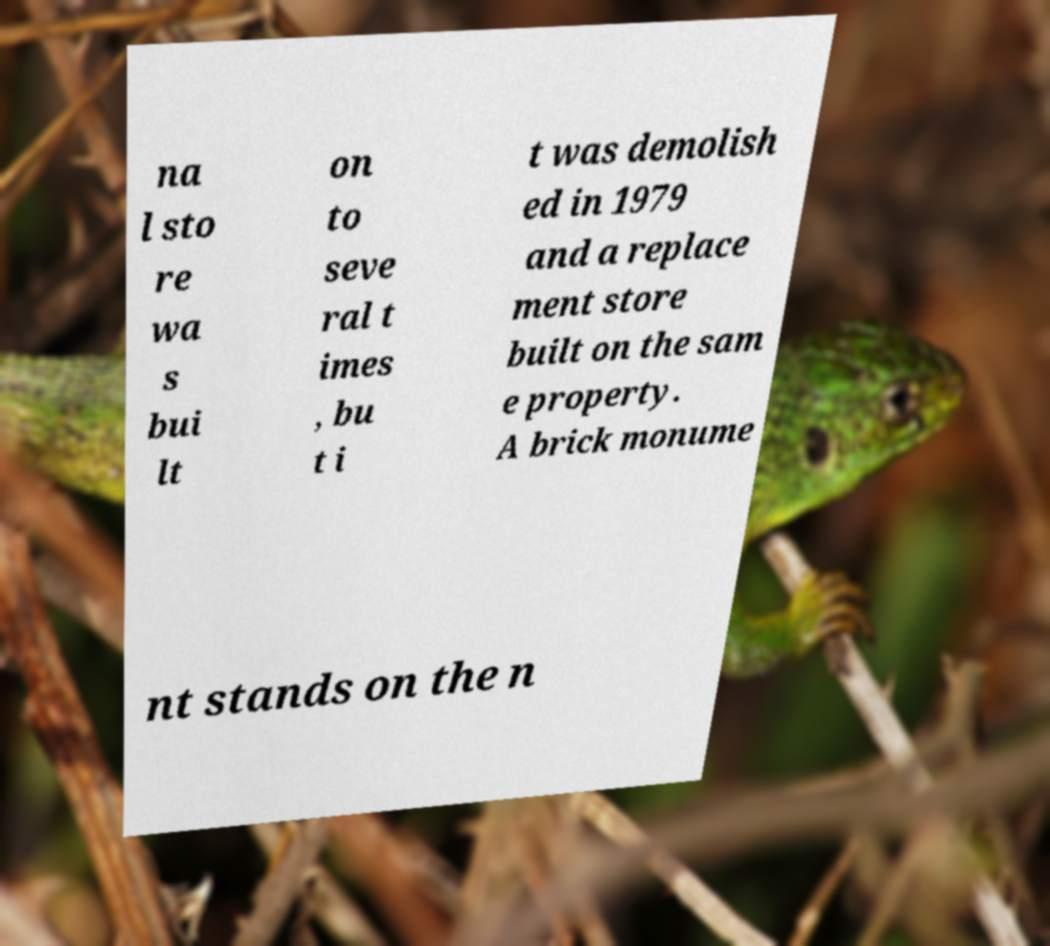For documentation purposes, I need the text within this image transcribed. Could you provide that? na l sto re wa s bui lt on to seve ral t imes , bu t i t was demolish ed in 1979 and a replace ment store built on the sam e property. A brick monume nt stands on the n 